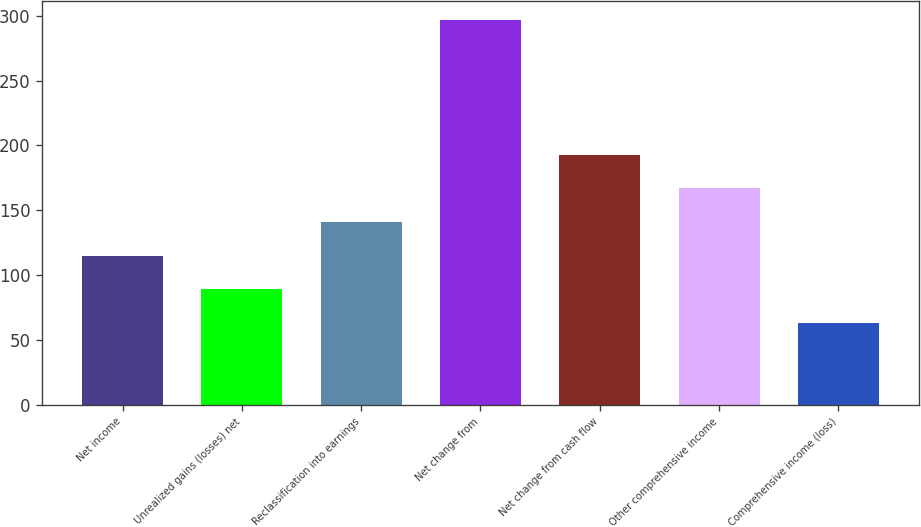<chart> <loc_0><loc_0><loc_500><loc_500><bar_chart><fcel>Net income<fcel>Unrealized gains (losses) net<fcel>Reclassification into earnings<fcel>Net change from<fcel>Net change from cash flow<fcel>Other comprehensive income<fcel>Comprehensive income (loss)<nl><fcel>115<fcel>89<fcel>141<fcel>297<fcel>193<fcel>167<fcel>63<nl></chart> 